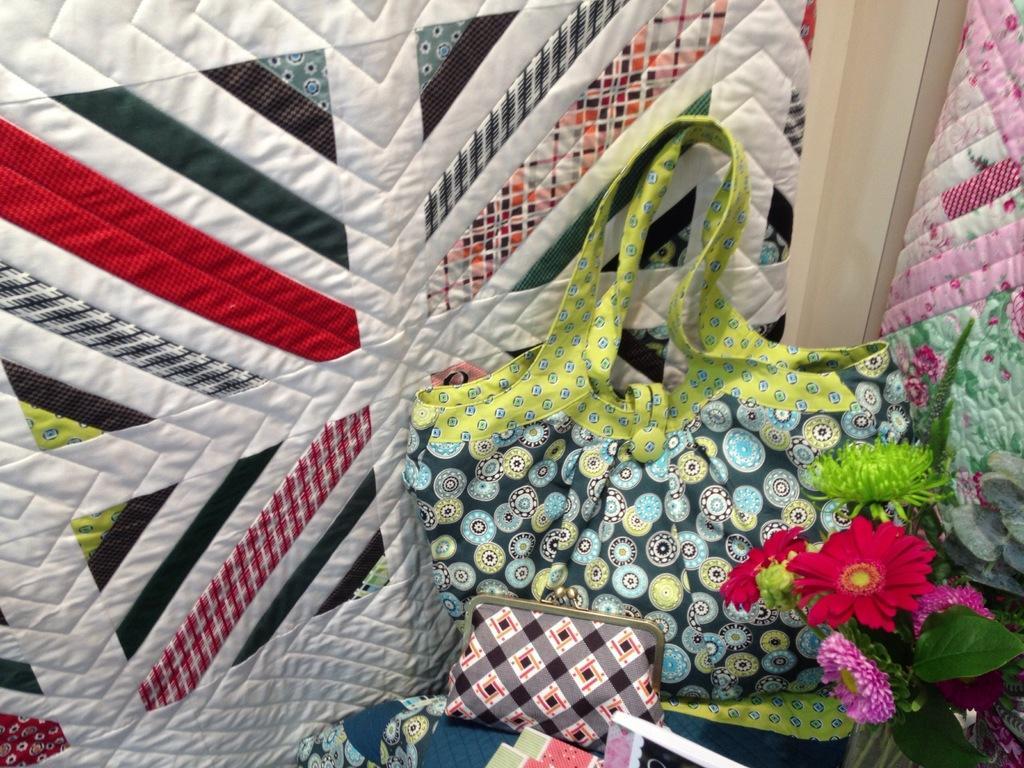Please provide a concise description of this image. In this image we can see bags, clothes, books, leaves, and flowers. 